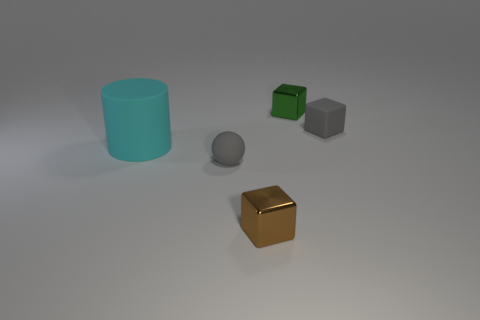There is a small brown cube; how many green things are in front of it?
Give a very brief answer. 0. What is the gray thing right of the shiny thing in front of the cyan matte thing made of?
Ensure brevity in your answer.  Rubber. Are there any matte balls that have the same color as the small matte block?
Your answer should be very brief. Yes. What size is the sphere that is made of the same material as the big thing?
Offer a very short reply. Small. Are there any other things that have the same color as the tiny matte sphere?
Give a very brief answer. Yes. There is a small cube that is behind the gray rubber block; what color is it?
Keep it short and to the point. Green. Are there any balls left of the small metallic object behind the cube that is in front of the matte ball?
Offer a terse response. Yes. Are there more objects that are right of the tiny gray sphere than small gray objects?
Keep it short and to the point. Yes. Do the tiny gray rubber object that is to the left of the gray cube and the green metal thing have the same shape?
Keep it short and to the point. No. Is there anything else that is made of the same material as the cyan cylinder?
Keep it short and to the point. Yes. 